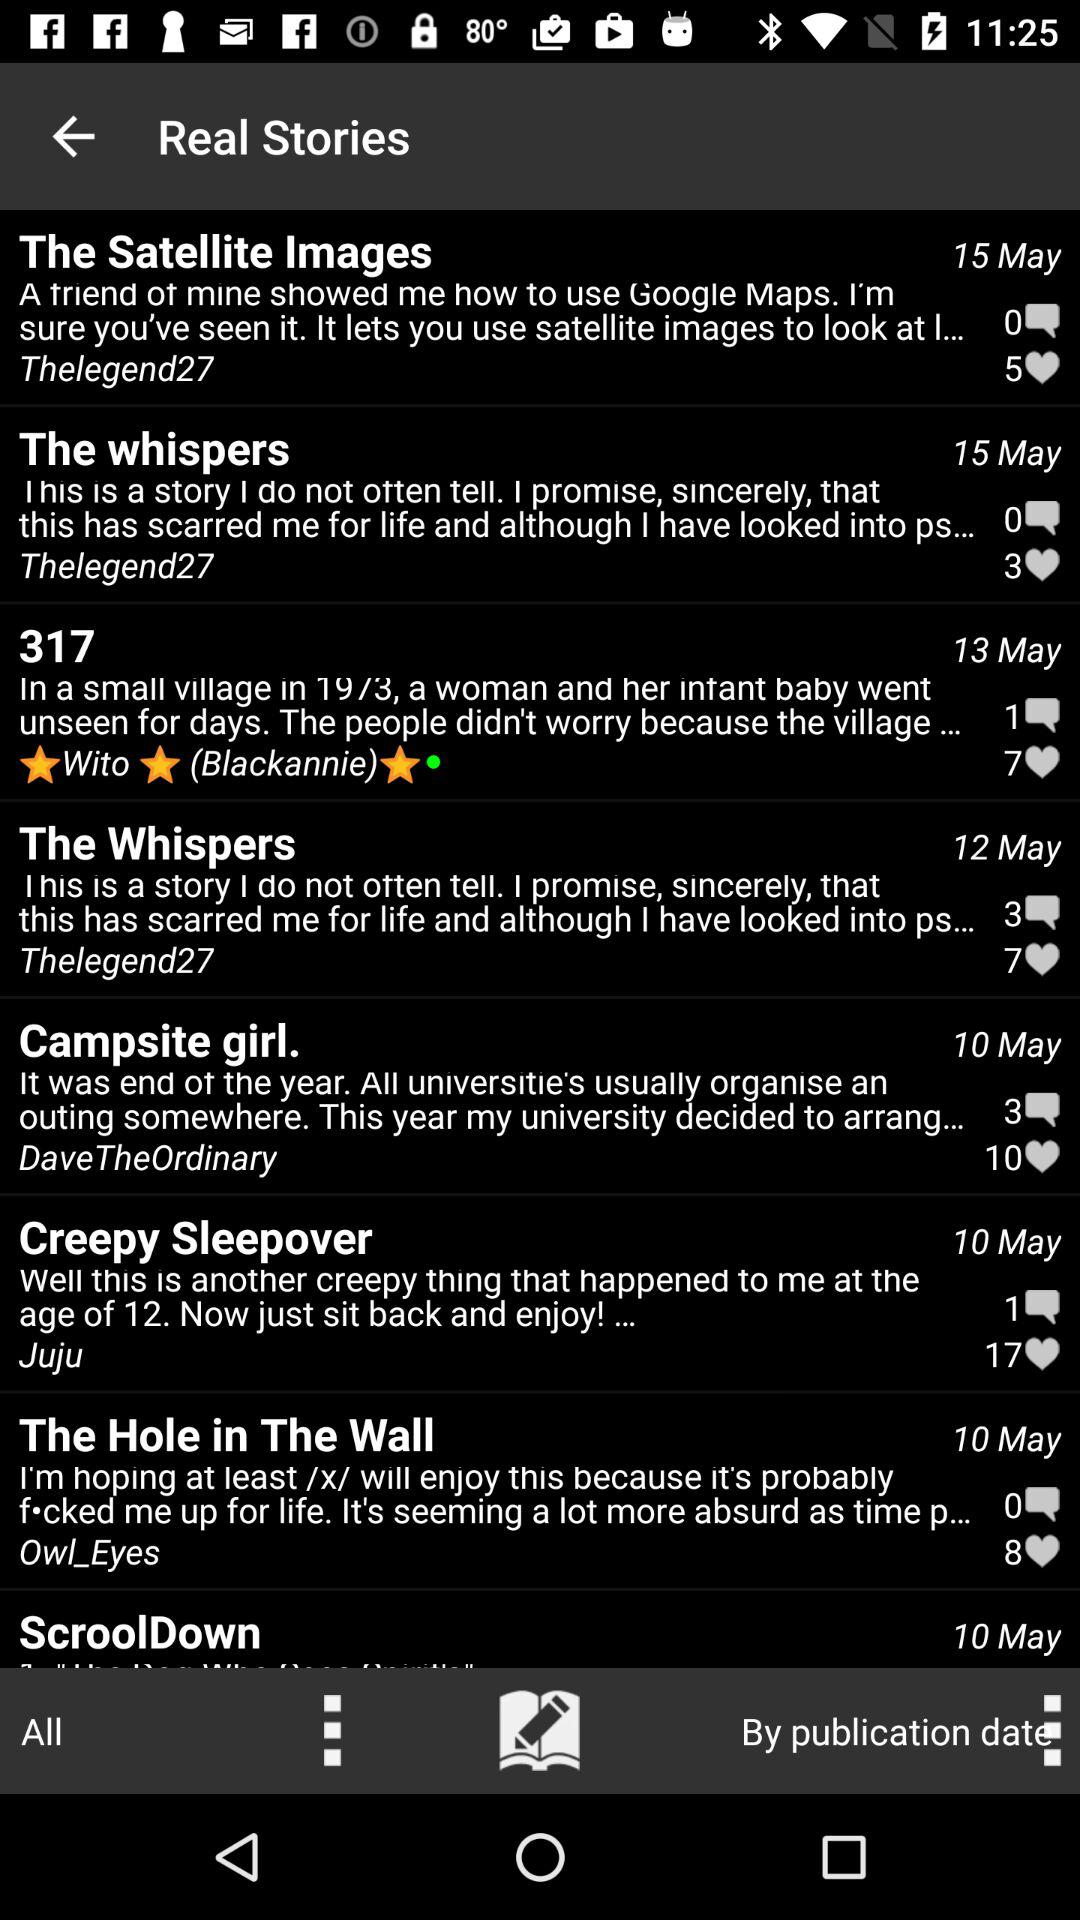How many likes are there on the campsite girl? There are 10 likes on campsite girl. 